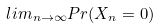Convert formula to latex. <formula><loc_0><loc_0><loc_500><loc_500>l i m _ { n \rightarrow \infty } P r ( X _ { n } = 0 )</formula> 